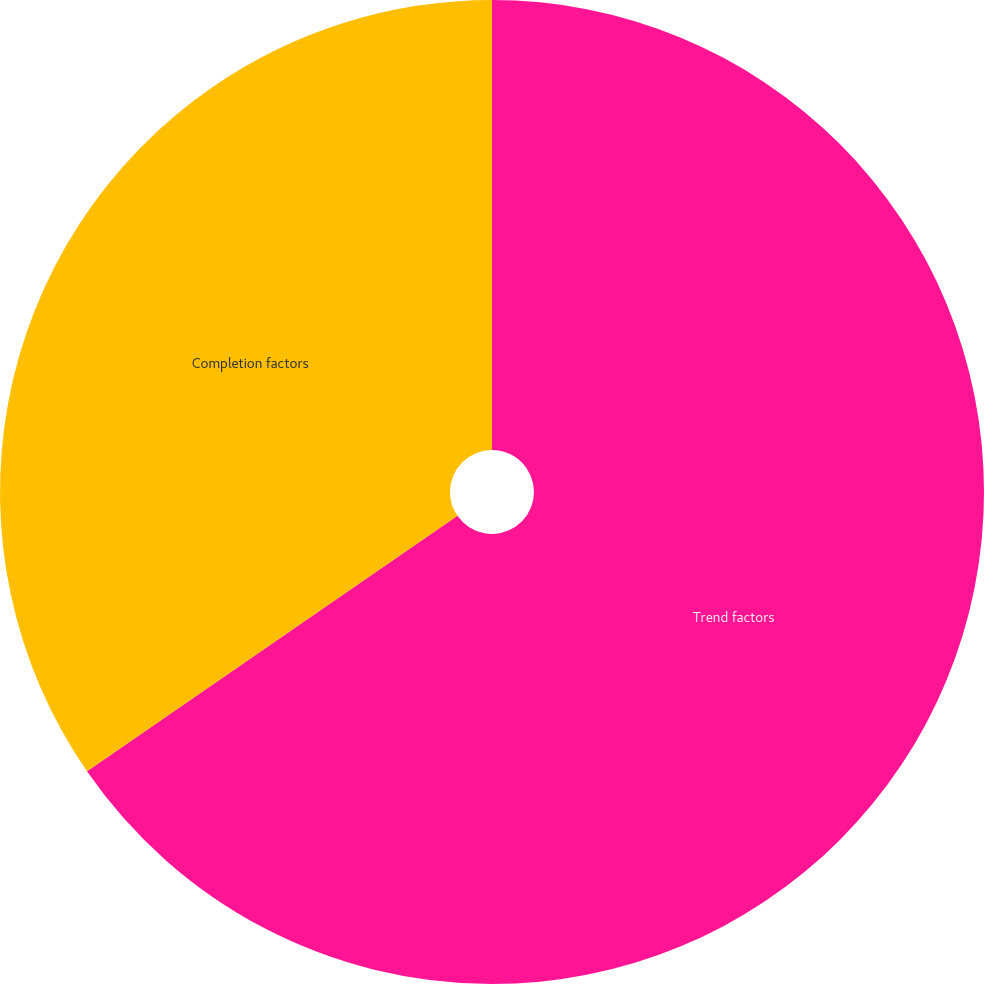<chart> <loc_0><loc_0><loc_500><loc_500><pie_chart><fcel>Trend factors<fcel>Completion factors<nl><fcel>65.39%<fcel>34.61%<nl></chart> 